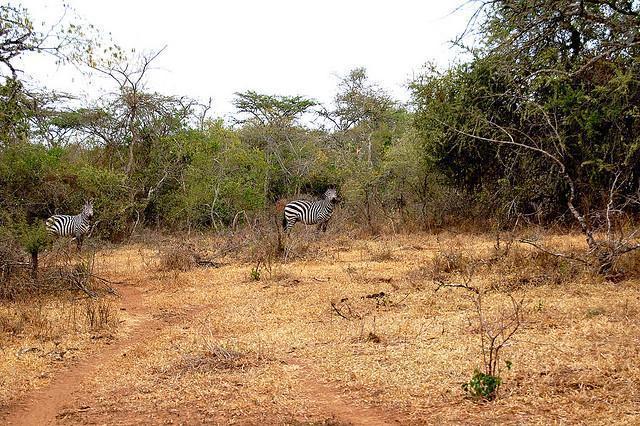How many legs do the striped animals have all together?
Give a very brief answer. 8. How many bikes are there?
Give a very brief answer. 0. 